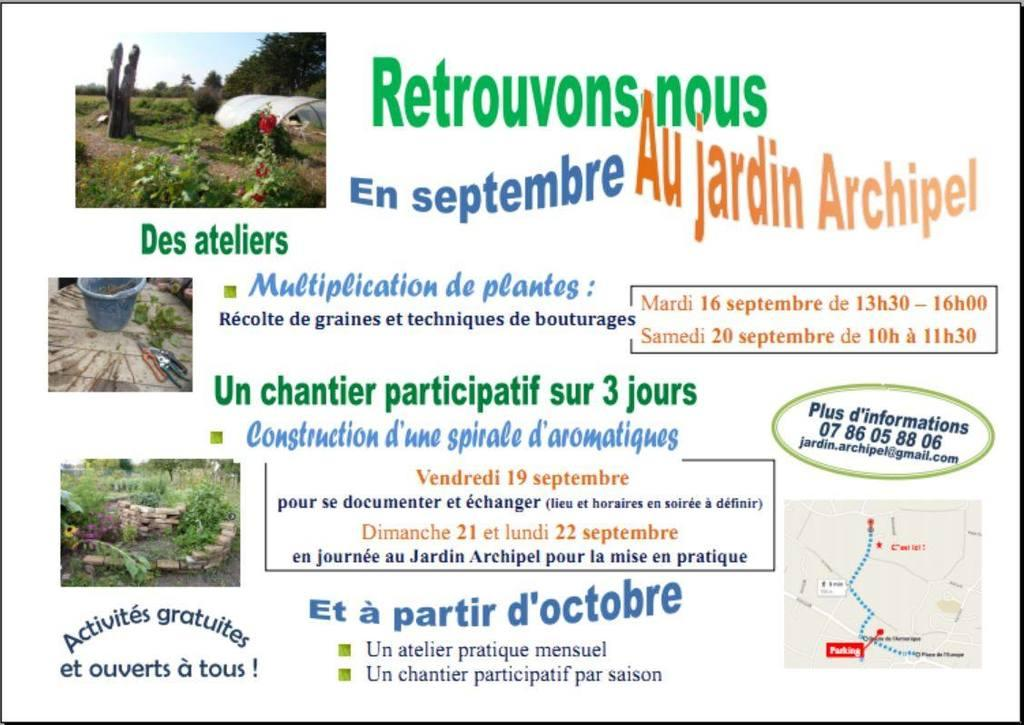How many pictures are in the image? There are four pictures in the image. What else can be seen in the image besides the pictures? There is a poster with text in the image. What type of force is being applied to the dress in the image? There is no dress present in the image, so it is not possible to determine if any force is being applied to it. 